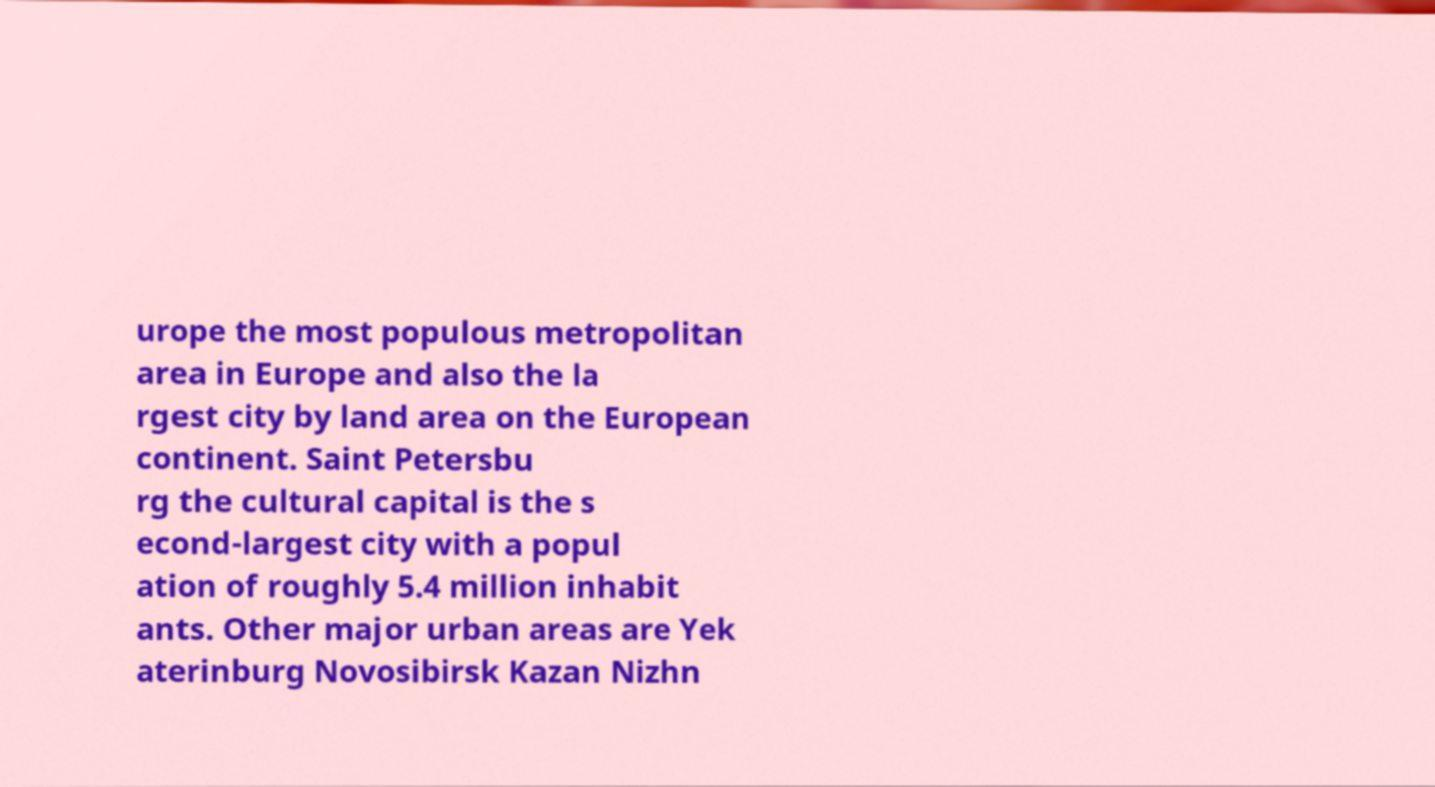What messages or text are displayed in this image? I need them in a readable, typed format. urope the most populous metropolitan area in Europe and also the la rgest city by land area on the European continent. Saint Petersbu rg the cultural capital is the s econd-largest city with a popul ation of roughly 5.4 million inhabit ants. Other major urban areas are Yek aterinburg Novosibirsk Kazan Nizhn 